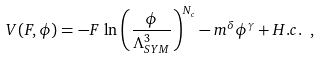Convert formula to latex. <formula><loc_0><loc_0><loc_500><loc_500>V ( F , \phi ) = - F \, \ln \left ( \frac { \phi } { \Lambda _ { S Y M } ^ { 3 } } \right ) ^ { N _ { c } } - m ^ { \delta } \phi ^ { \gamma } + H . c . \ ,</formula> 